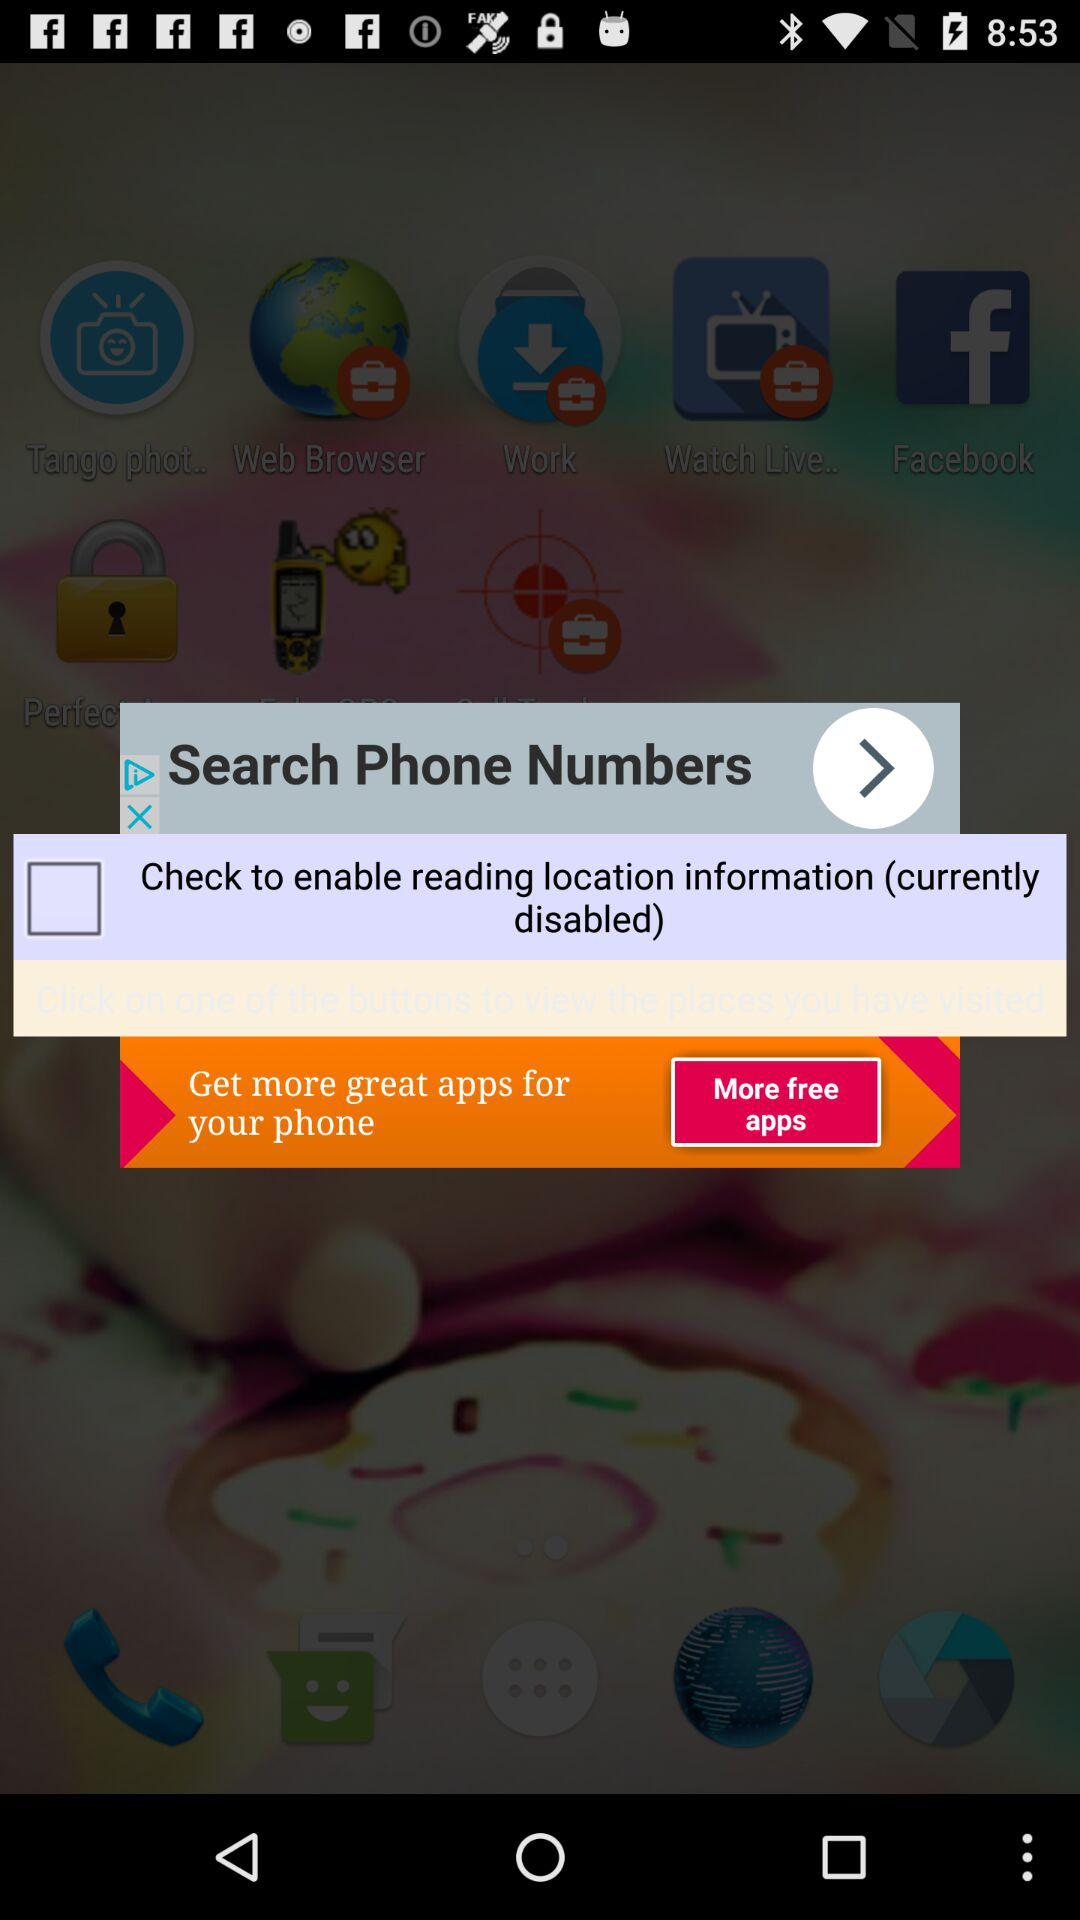What's the status of "reading location information"? The status is "off". 